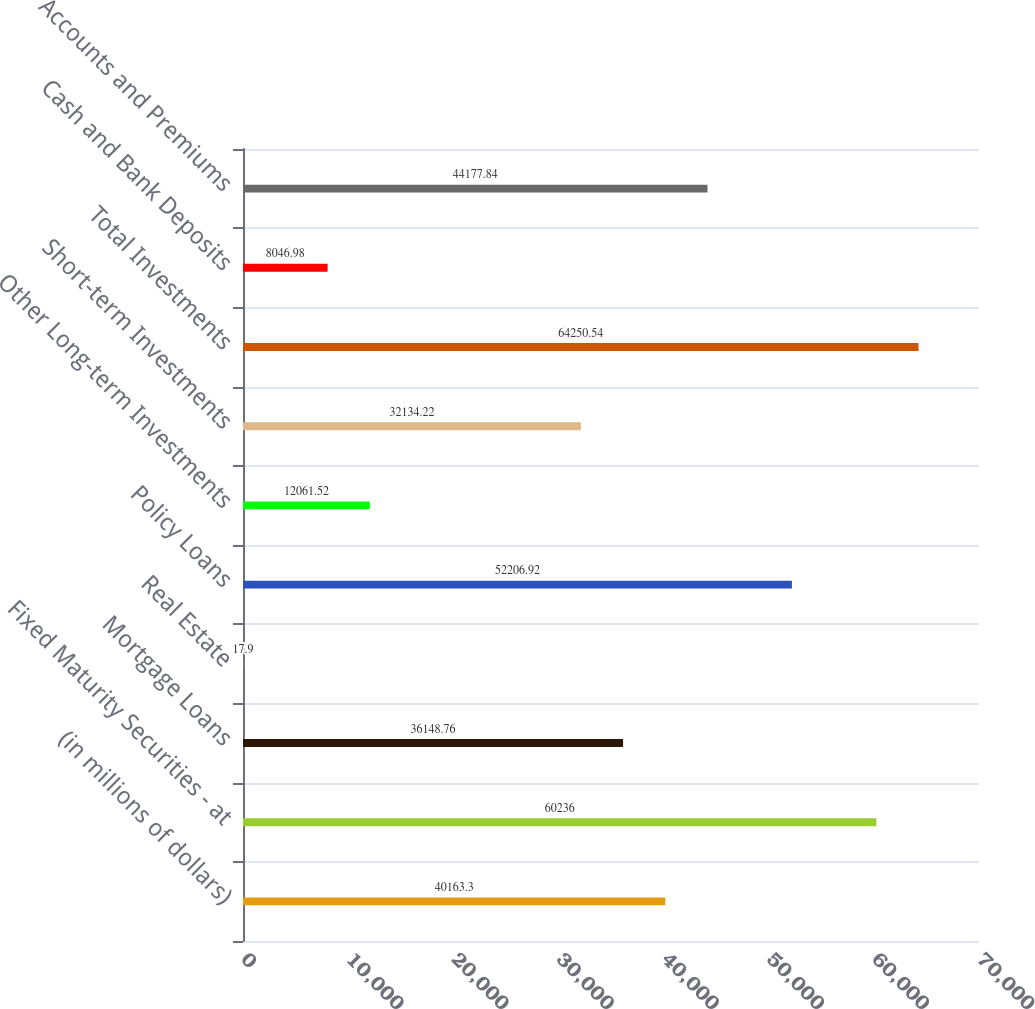Convert chart. <chart><loc_0><loc_0><loc_500><loc_500><bar_chart><fcel>(in millions of dollars)<fcel>Fixed Maturity Securities - at<fcel>Mortgage Loans<fcel>Real Estate<fcel>Policy Loans<fcel>Other Long-term Investments<fcel>Short-term Investments<fcel>Total Investments<fcel>Cash and Bank Deposits<fcel>Accounts and Premiums<nl><fcel>40163.3<fcel>60236<fcel>36148.8<fcel>17.9<fcel>52206.9<fcel>12061.5<fcel>32134.2<fcel>64250.5<fcel>8046.98<fcel>44177.8<nl></chart> 